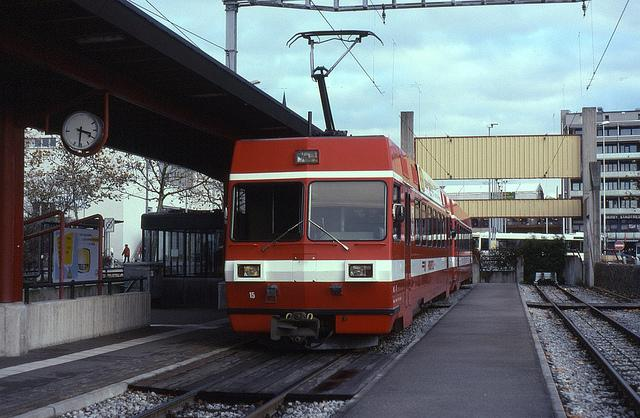How many hours until midnight? Please explain your reasoning. eight. The clock at the train station says it is 3:30 and about 8 hours until midnight. 